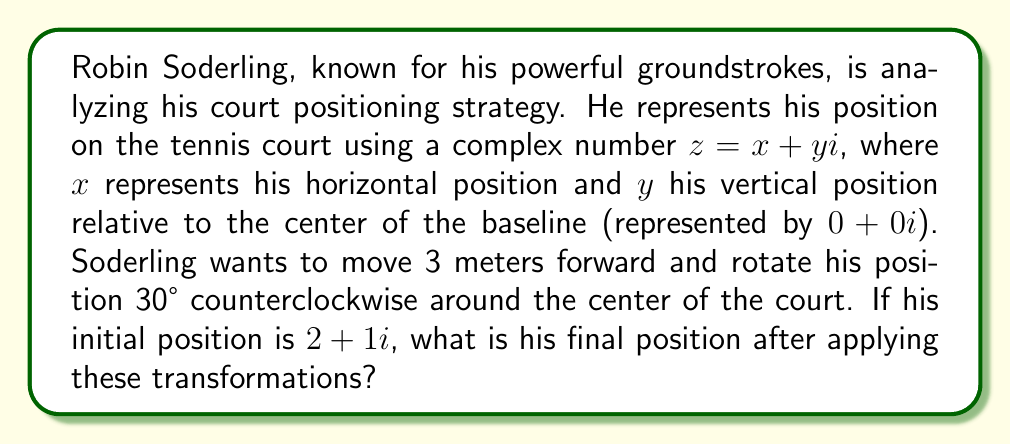Give your solution to this math problem. To solve this problem, we'll use complex number transformations:

1) First, let's move Soderling 3 meters forward. In tennis court coordinates, moving forward is equivalent to adding to the imaginary part:

   $z_1 = 2 + 1i + 3i = 2 + 4i$

2) Now, we need to rotate this position 30° counterclockwise around the origin. The formula for rotation by an angle $\theta$ is:

   $z_2 = z_1 (\cos\theta + i\sin\theta)$

   For 30°, $\cos 30° = \frac{\sqrt{3}}{2}$ and $\sin 30° = \frac{1}{2}$

3) Let's apply the rotation:

   $z_2 = (2 + 4i) (\frac{\sqrt{3}}{2} + \frac{1}{2}i)$

4) Multiply these complex numbers:

   $z_2 = (2\frac{\sqrt{3}}{2} - 4\frac{1}{2}) + (2\frac{1}{2} + 4\frac{\sqrt{3}}{2})i$

5) Simplify:

   $z_2 = (\sqrt{3} - 2) + (1 + 2\sqrt{3})i$

This represents Soderling's final position after the transformations.
Answer: $(\sqrt{3} - 2) + (1 + 2\sqrt{3})i$ 